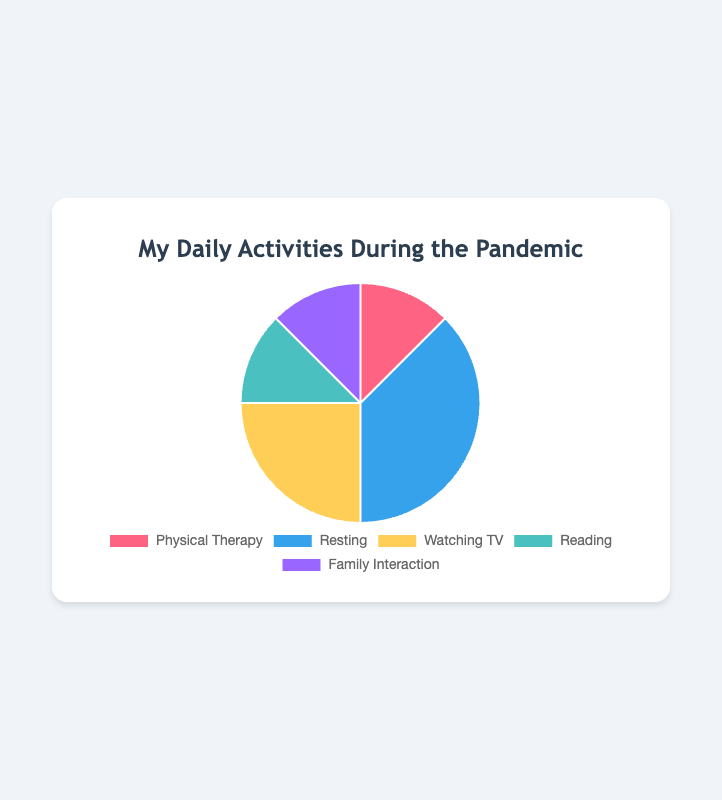Which activity takes up the most time daily? By looking at the pie chart, we can observe that the section for "Resting" is the largest. This indicates that "Resting" is the activity that takes up the most time daily.
Answer: Resting How much total time is spent on Physical Therapy, Reading, and Family Interaction combined? To find the total time for these activities, we need to sum their respective time spent: Physical Therapy (2 hours) + Reading (2 hours) + Family Interaction (2 hours). The total is 2 + 2 + 2 = 6 hours.
Answer: 6 hours Which activity takes more time: Watching TV or Reading? By comparing the sizes of the sections, we see that "Watching TV" has a larger section than "Reading." The time spent on Watching TV is 4 hours, while Reading is 2 hours. Therefore, Watching TV takes more time.
Answer: Watching TV How does the time spent on Reading compare to the time spent on Physical Therapy? Both "Reading" and "Physical Therapy" have equal sections in the pie chart. Each of these activities takes up 2 hours daily. Hence, the time spent on Reading is equal to the time spent on Physical Therapy.
Answer: Equal If you reduce the time spent resting by 2 hours and distribute it equally among Physical Therapy, Reading, and Family Interaction, how much time will be spent on each of these three activities now? First, reduce the time spent resting by 2 hours: 6 hours - 2 hours = 4 hours. Next, distribute these 2 hours equally among the three activities. Each will get an additional 2/3 ≈ 0.67 hours. So, the new time spent on each activity is: Physical Therapy (2 + 0.67 ≈ 2.67 hours), Reading (2 + 0.67 ≈ 2.67 hours), Family Interaction (2 + 0.67 ≈ 2.67 hours).
Answer: Approximately 2.67 hours each Which activities have the same time allocation? By observing the pie chart, we can see that "Physical Therapy," "Reading," and "Family Interaction" all have sections of equal size. Each of these activities takes up 2 hours daily.
Answer: Physical Therapy, Reading, Family Interaction How much more time is spent Resting compared to Physical Therapy? The time spent resting is 6 hours, and the time spent on Physical Therapy is 2 hours. The difference is 6 - 2 = 4 hours. Therefore, 4 more hours are spent resting compared to Physical Therapy.
Answer: 4 hours What percentage of the day is spent Watching TV? The total hours spent on all activities sum up to 16 hours (2 + 6 + 4 + 2 + 2). Watching TV takes up 4 hours. To calculate the percentage: (4 / 16) * 100% = 25%.
Answer: 25% What is the ratio of time spent resting to time spent on family interaction? Resting takes 6 hours, and Family Interaction takes 2 hours. The ratio is then 6 to 2, which simplifies to 3 to 1.
Answer: 3:1 What fraction of the day is spent on activities other than watching TV? The total hours of activities are 16, with 4 hours spent on Watching TV. Therefore, the time spent on other activities is 16 - 4 = 12 hours. The fraction is thus 12/16, which simplifies to 3/4 of the day.
Answer: 3/4 